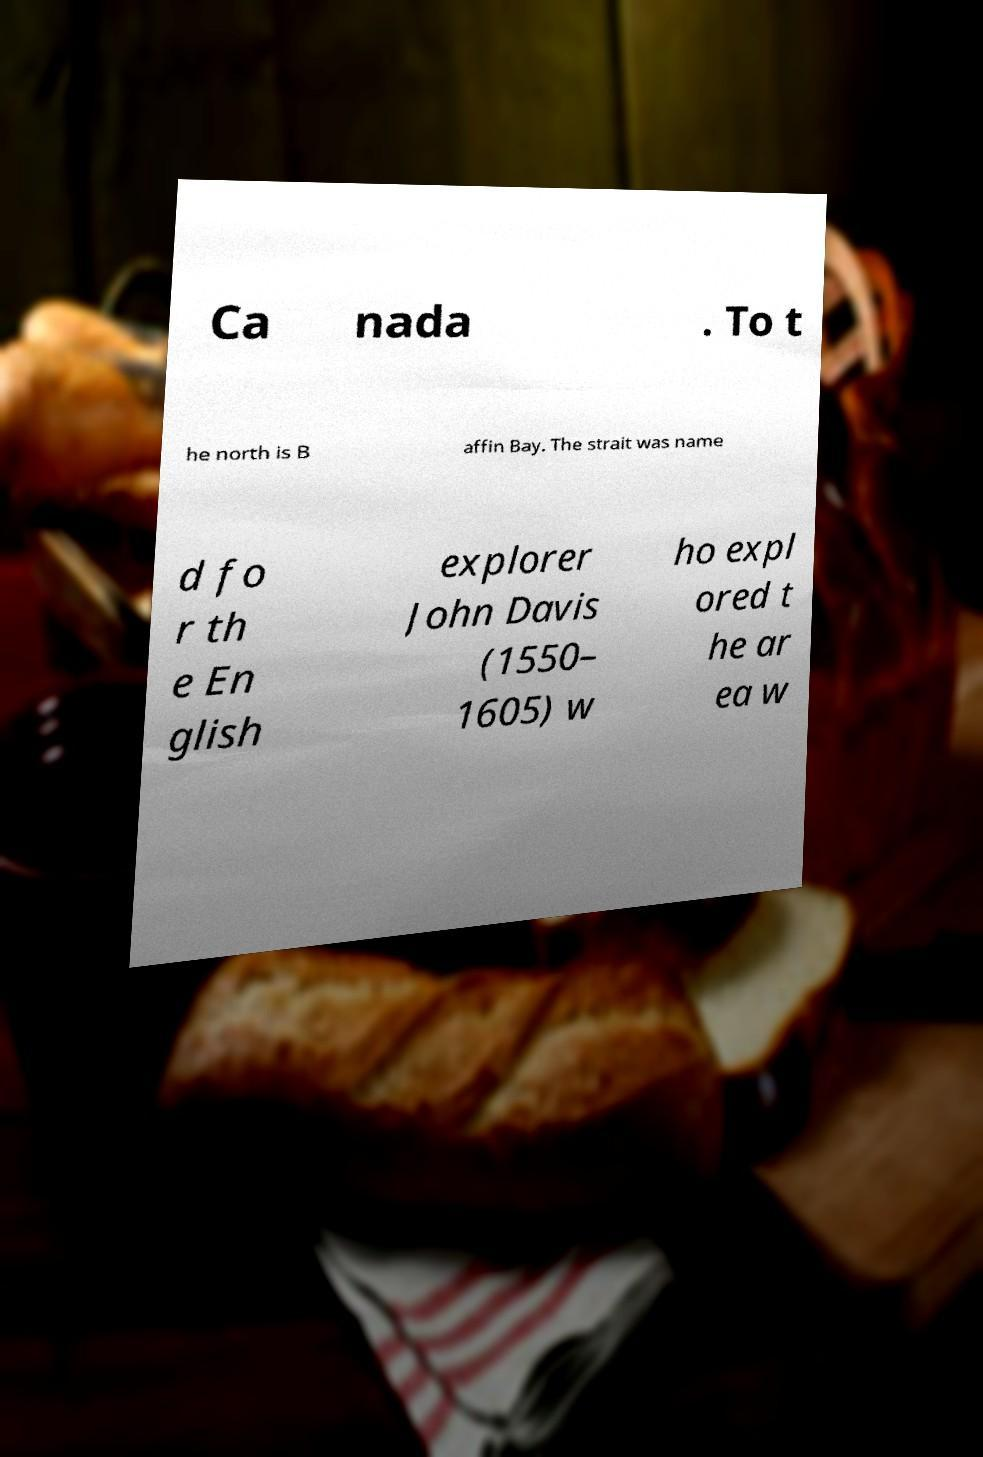I need the written content from this picture converted into text. Can you do that? Ca nada . To t he north is B affin Bay. The strait was name d fo r th e En glish explorer John Davis (1550– 1605) w ho expl ored t he ar ea w 